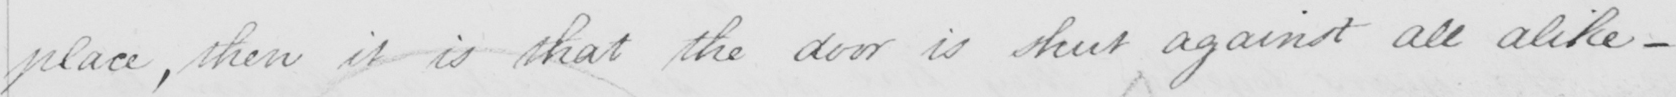Transcribe the text shown in this historical manuscript line. place , then it is that the door is shut against all alike  _ 